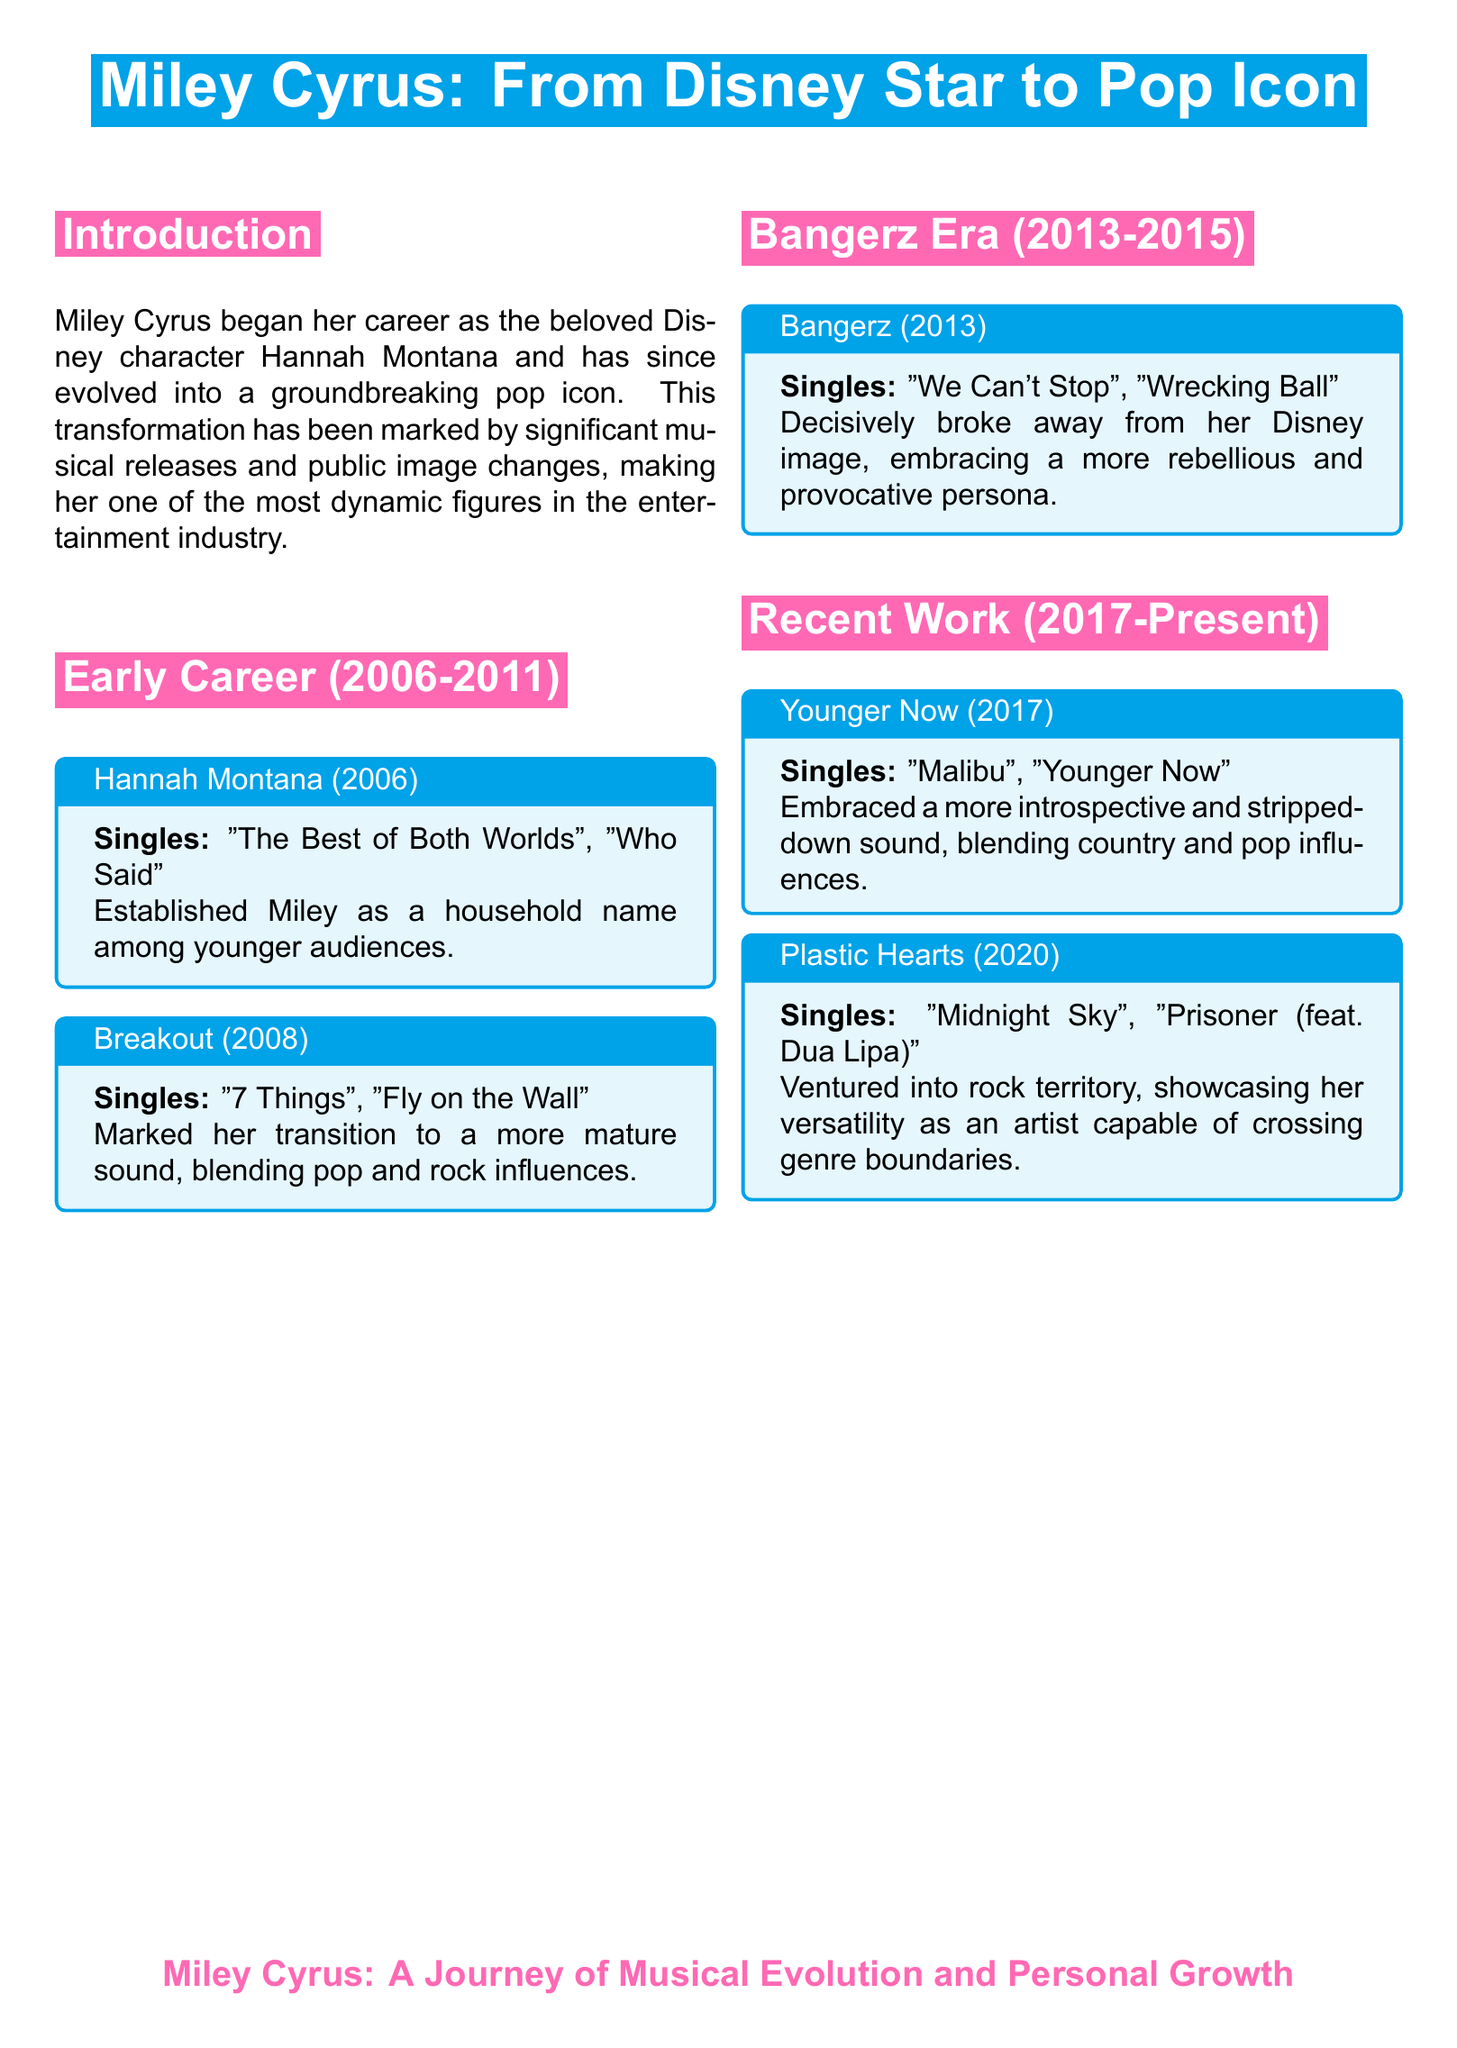What was Miley Cyrus's character on Disney Channel? Miley Cyrus became famous for her role as Hannah Montana on Disney Channel.
Answer: Hannah Montana When did Miley release the album "Bangerz"? "Bangerz" was released in 2013 as part of her transformation into a pop icon.
Answer: 2013 What is one of the singles from the "Younger Now" album? The document mentions "Malibu" as a single from the "Younger Now" album.
Answer: Malibu Which album features the single "Wrecking Ball"? "Wrecking Ball" is a single from the "Bangerz" album that marked a pivotal moment in her career.
Answer: Bangerz What genre did Miley explore in her "Plastic Hearts" album? The "Plastic Hearts" album ventured into the rock genre, showcasing her versatility.
Answer: Rock What was one significant change in Miley's image during the Bangerz era? During the Bangerz era, Miley broke away from her Disney image and embraced a more rebellious persona.
Answer: Rebellious Name one of the singles from the "Plastic Hearts" album. The document lists "Midnight Sky" as one of the singles from the "Plastic Hearts" album.
Answer: Midnight Sky In what year did Miley Cyrus's career begin as Hannah Montana? Miley Cyrus's character of Hannah Montana debuted in 2006, marking the start of her career.
Answer: 2006 What type of sound did Miley embrace in her "Younger Now" album? Miley embraced a more introspective and stripped-down sound in her "Younger Now" album.
Answer: Introspective 